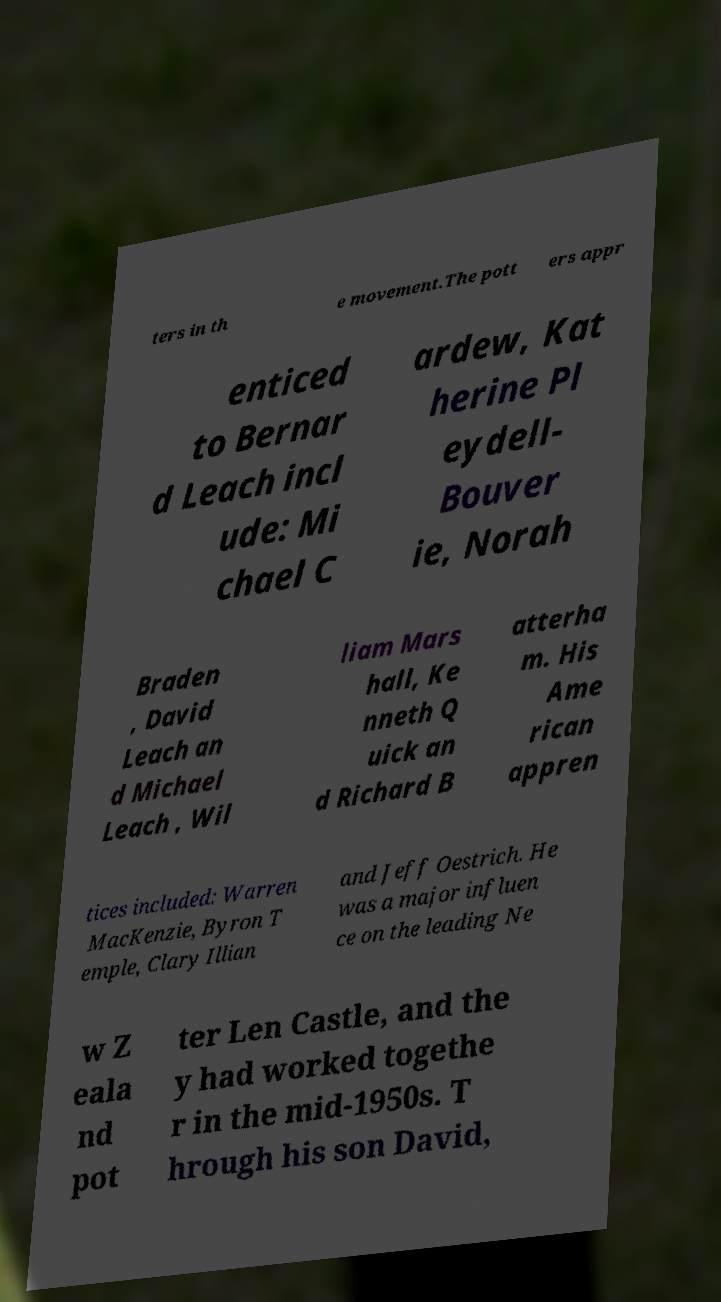I need the written content from this picture converted into text. Can you do that? ters in th e movement.The pott ers appr enticed to Bernar d Leach incl ude: Mi chael C ardew, Kat herine Pl eydell- Bouver ie, Norah Braden , David Leach an d Michael Leach , Wil liam Mars hall, Ke nneth Q uick an d Richard B atterha m. His Ame rican appren tices included: Warren MacKenzie, Byron T emple, Clary Illian and Jeff Oestrich. He was a major influen ce on the leading Ne w Z eala nd pot ter Len Castle, and the y had worked togethe r in the mid-1950s. T hrough his son David, 